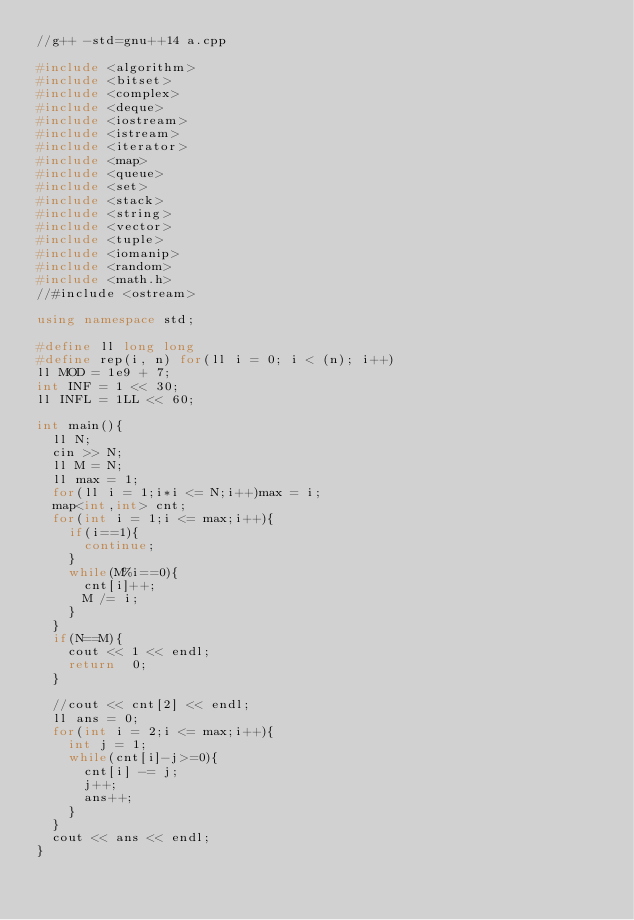<code> <loc_0><loc_0><loc_500><loc_500><_C++_>//g++ -std=gnu++14 a.cpp

#include <algorithm>
#include <bitset>
#include <complex>
#include <deque>
#include <iostream>
#include <istream>
#include <iterator>
#include <map>
#include <queue>
#include <set>
#include <stack>
#include <string>
#include <vector>
#include <tuple>
#include <iomanip>
#include <random>
#include <math.h>
//#include <ostream>

using namespace std;

#define ll long long
#define rep(i, n) for(ll i = 0; i < (n); i++)
ll MOD = 1e9 + 7;
int INF = 1 << 30;
ll INFL = 1LL << 60;

int main(){
  ll N;
  cin >> N;
  ll M = N;
  ll max = 1;
  for(ll i = 1;i*i <= N;i++)max = i;
  map<int,int> cnt;
  for(int i = 1;i <= max;i++){
    if(i==1){
      continue;
    }
    while(M%i==0){
      cnt[i]++;
      M /= i;
    }
  }
  if(N==M){
    cout << 1 << endl;
    return  0;
  }

  //cout << cnt[2] << endl;
  ll ans = 0;
  for(int i = 2;i <= max;i++){
    int j = 1;
    while(cnt[i]-j>=0){
      cnt[i] -= j;
      j++;
      ans++;
    }
  }
  cout << ans << endl;
}
</code> 